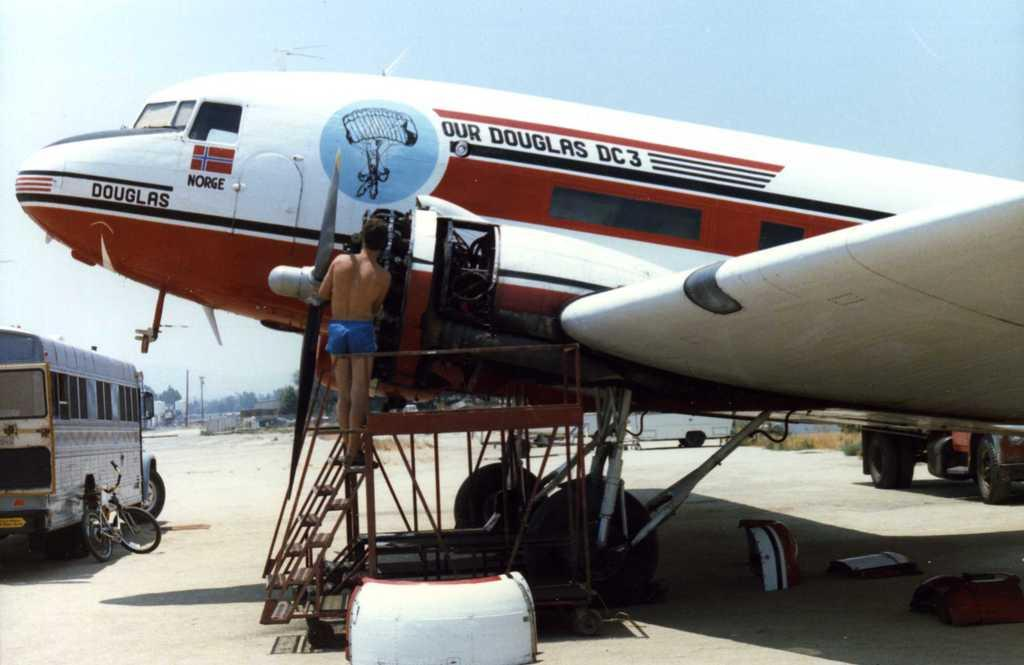What is the main subject in the center of the image? There is an aeroplane in the center of the image. Can you describe the person in the image? There is a person standing on the stairs. What other objects can be seen in the image? There are vehicles in the image. What can be seen in the background of the image? There are trees, poles, and the sky visible in the background. What type of cakes are being prepared on the aeroplane in the image? There are no cakes present in the image, and the aeroplane is not being used for preparing food. How much salt is visible on the person standing on the stairs in the image? There is no salt visible on the person standing on the stairs in the image. 